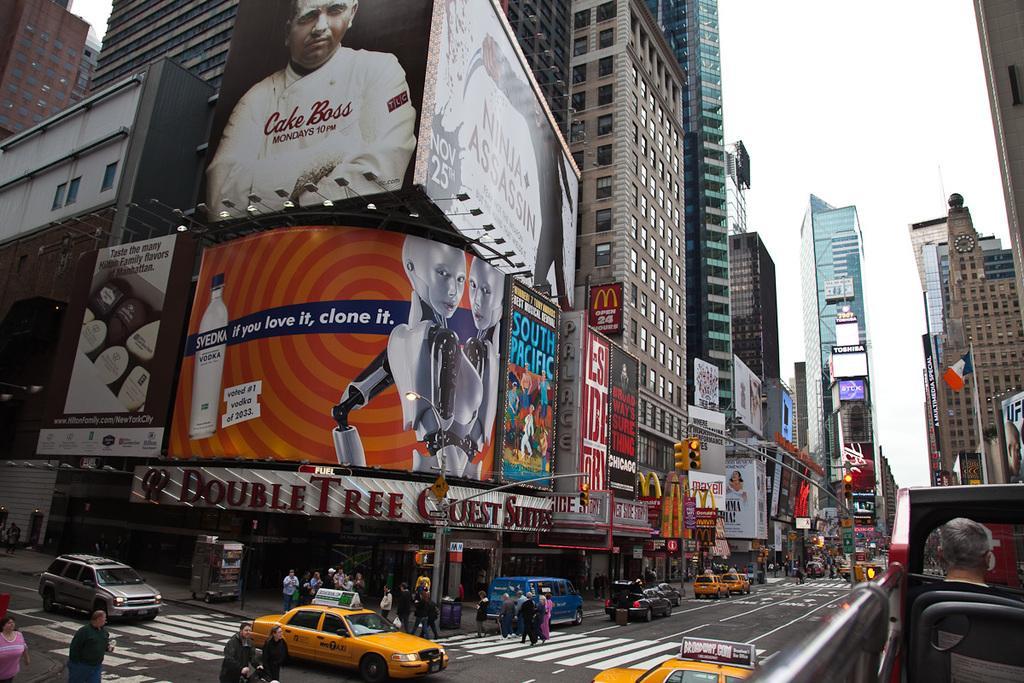Please provide a concise description of this image. In the center of the image we can see buildings, advertisements, posters, stores, persons , road, vehicles, flag, traffic signals and sky. 